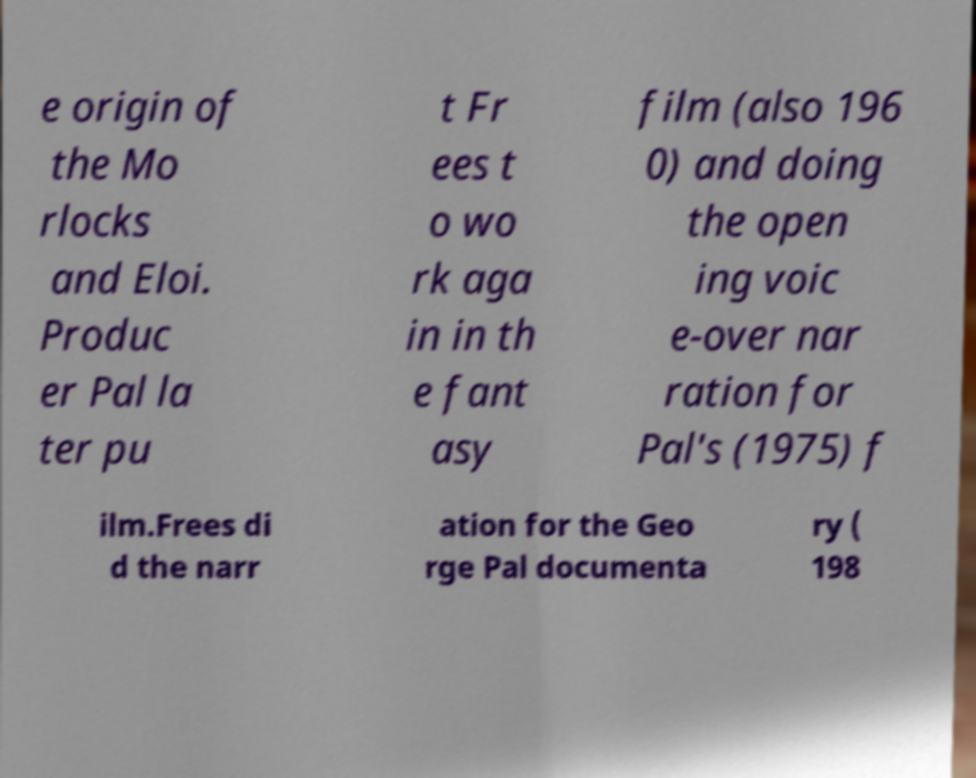Can you accurately transcribe the text from the provided image for me? e origin of the Mo rlocks and Eloi. Produc er Pal la ter pu t Fr ees t o wo rk aga in in th e fant asy film (also 196 0) and doing the open ing voic e-over nar ration for Pal's (1975) f ilm.Frees di d the narr ation for the Geo rge Pal documenta ry ( 198 